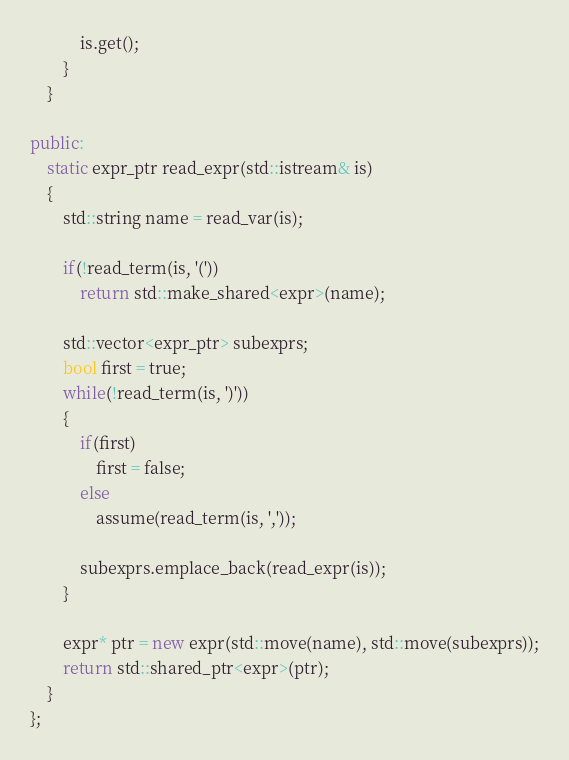<code> <loc_0><loc_0><loc_500><loc_500><_C++_>			is.get();
		}
	}

public:
	static expr_ptr read_expr(std::istream& is)
	{
		std::string name = read_var(is);

		if(!read_term(is, '('))
			return std::make_shared<expr>(name);

		std::vector<expr_ptr> subexprs;
		bool first = true;
		while(!read_term(is, ')'))
		{
			if(first)
				first = false;
			else
				assume(read_term(is, ','));

			subexprs.emplace_back(read_expr(is));
		}

		expr* ptr = new expr(std::move(name), std::move(subexprs));
		return std::shared_ptr<expr>(ptr);
	}
};
</code> 